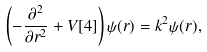Convert formula to latex. <formula><loc_0><loc_0><loc_500><loc_500>\left ( - \frac { \partial ^ { 2 } } { \partial r ^ { 2 } } + V [ 4 ] \right ) \psi ( r ) = k ^ { 2 } \psi ( r ) ,</formula> 